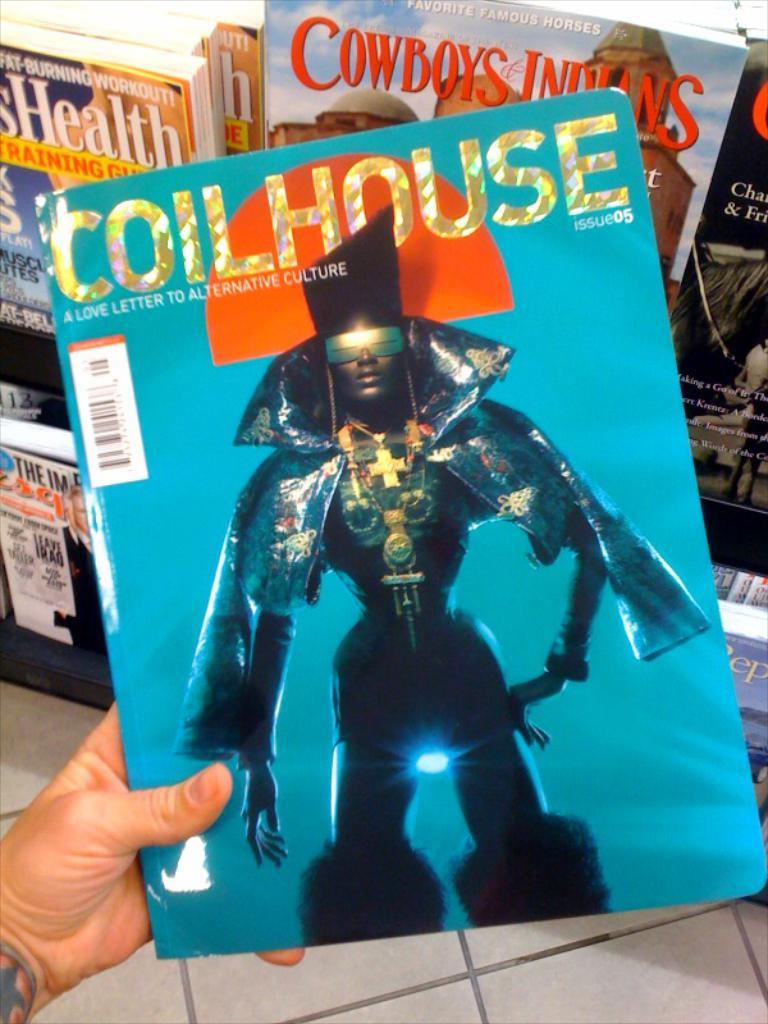<image>
Write a terse but informative summary of the picture. The blue and orange magazine is titled the Coilhouse 